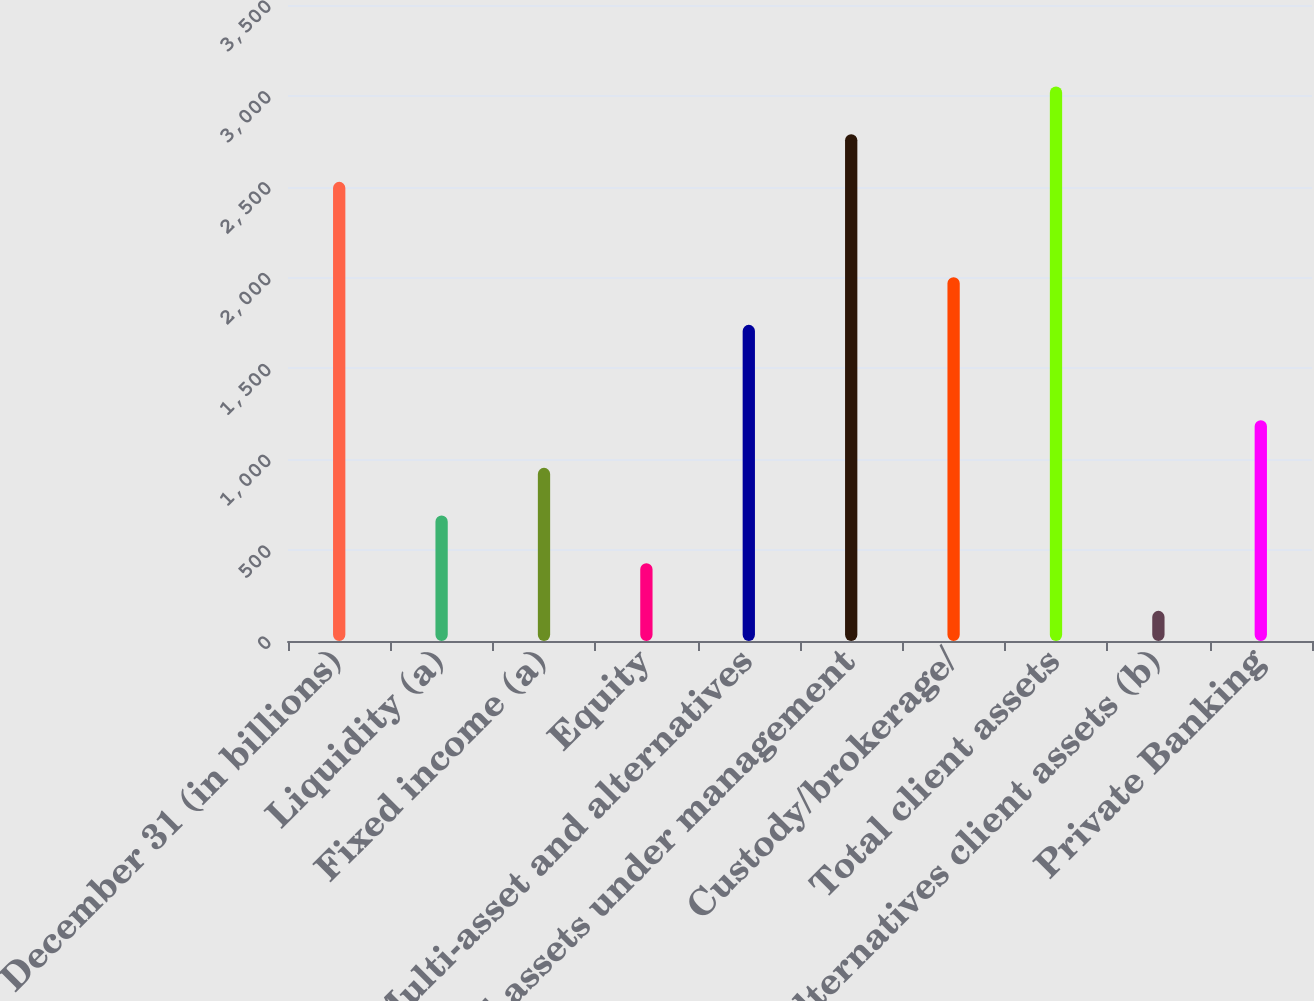<chart> <loc_0><loc_0><loc_500><loc_500><bar_chart><fcel>December 31 (in billions)<fcel>Liquidity (a)<fcel>Fixed income (a)<fcel>Equity<fcel>Multi-asset and alternatives<fcel>Total assets under management<fcel>Custody/brokerage/<fcel>Total client assets<fcel>Alternatives client assets (b)<fcel>Private Banking<nl><fcel>2526.7<fcel>690.6<fcel>952.9<fcel>428.3<fcel>1739.8<fcel>2789<fcel>2002.1<fcel>3051.3<fcel>166<fcel>1215.2<nl></chart> 